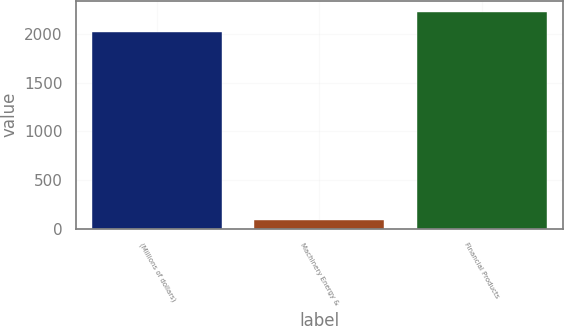Convert chart to OTSL. <chart><loc_0><loc_0><loc_500><loc_500><bar_chart><fcel>(Millions of dollars)<fcel>Machinery Energy &<fcel>Financial Products<nl><fcel>2023<fcel>92<fcel>2229.6<nl></chart> 